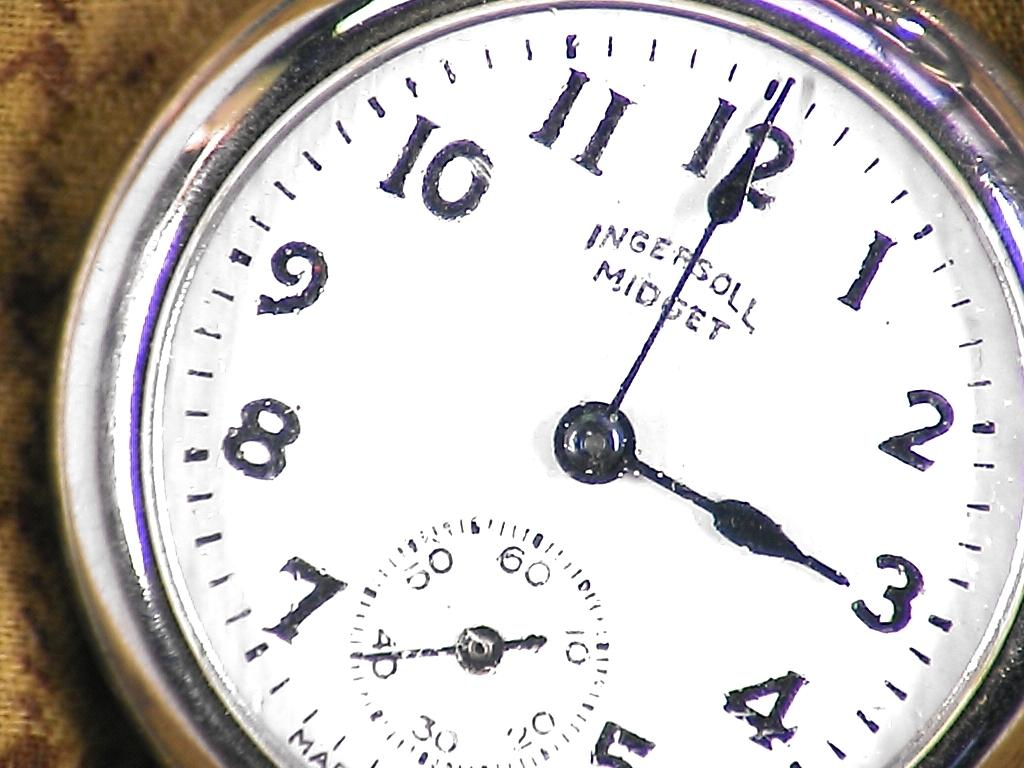<image>
Provide a brief description of the given image. Watch face that says Ingersoll Midget and 3:00 